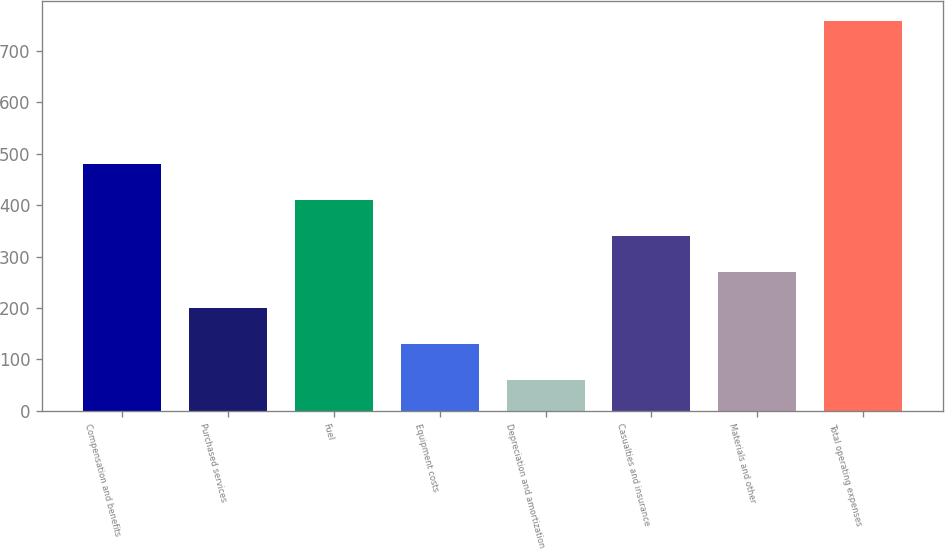Convert chart. <chart><loc_0><loc_0><loc_500><loc_500><bar_chart><fcel>Compensation and benefits<fcel>Purchased services<fcel>Fuel<fcel>Equipment costs<fcel>Depreciation and amortization<fcel>Casualties and insurance<fcel>Materials and other<fcel>Total operating expenses<nl><fcel>479.58<fcel>199.86<fcel>409.65<fcel>129.93<fcel>60<fcel>339.72<fcel>269.79<fcel>759.3<nl></chart> 